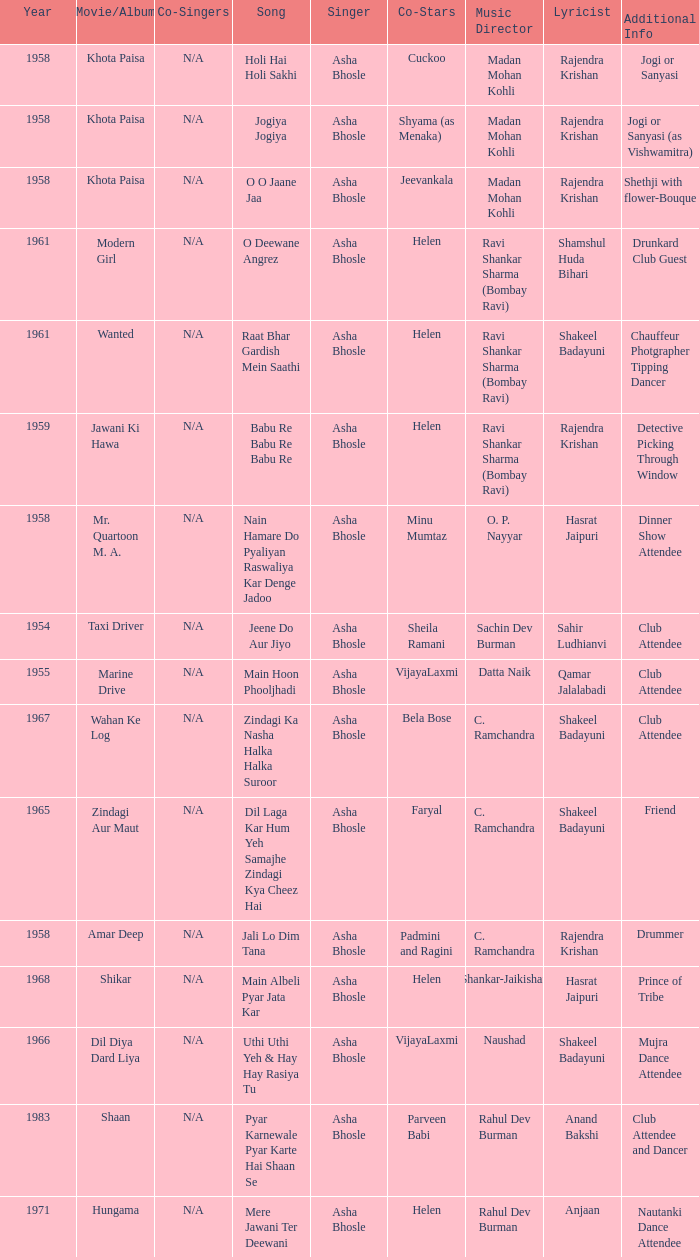What movie did Vijayalaxmi Co-star in and Shakeel Badayuni write the lyrics? Dil Diya Dard Liya. 